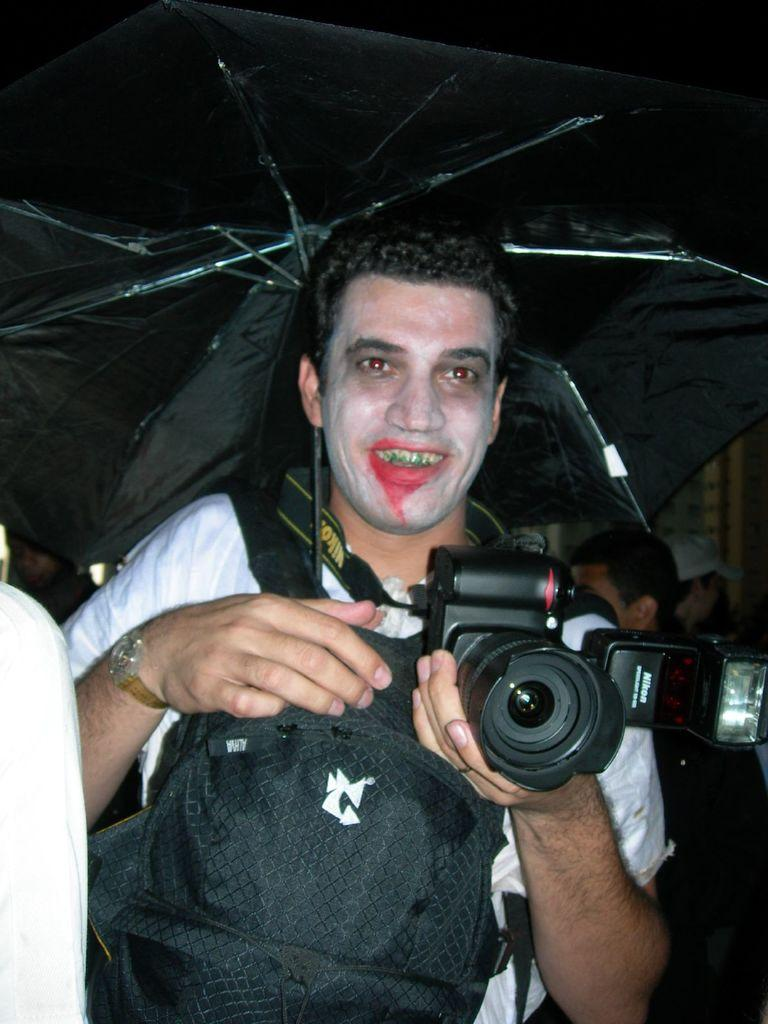What is the man in the image doing? The man is holding a camera in the image. What is the man's facial expression in the image? The man is smiling in the image. What object is the man holding in addition to the camera? The man is holding an umbrella in the image. What type of fish can be seen swimming near the man in the image? There is no fish present in the image; it features a man holding a camera and an umbrella. How does the tramp contribute to the scene in the image? There is no tramp present in the image; it only features a man holding a camera and an umbrella. 